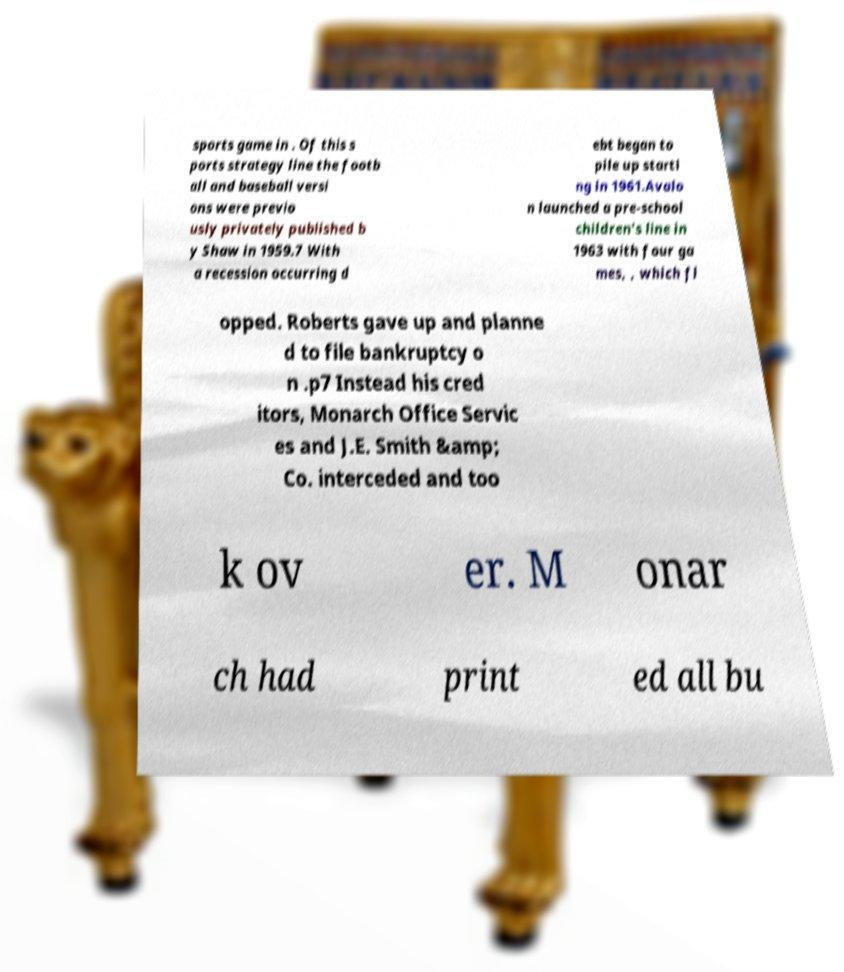Could you extract and type out the text from this image? sports game in . Of this s ports strategy line the footb all and baseball versi ons were previo usly privately published b y Shaw in 1959.7 With a recession occurring d ebt began to pile up starti ng in 1961.Avalo n launched a pre-school children's line in 1963 with four ga mes, , which fl opped. Roberts gave up and planne d to file bankruptcy o n .p7 Instead his cred itors, Monarch Office Servic es and J.E. Smith &amp; Co. interceded and too k ov er. M onar ch had print ed all bu 